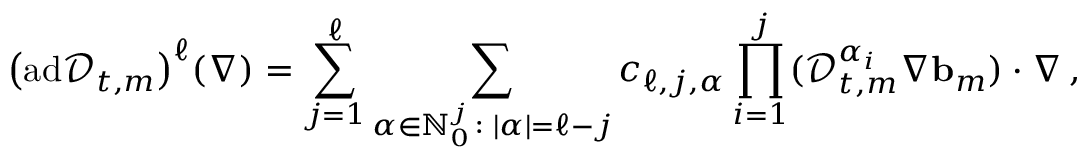<formula> <loc_0><loc_0><loc_500><loc_500>\left ( a d \ m a t h s c r { D } _ { t , m } \right ) ^ { \ell } ( \nabla ) = \sum _ { j = 1 } ^ { \ell } \sum _ { { \alpha } \in { \mathbb { N } } _ { 0 } ^ { j } \colon | { \alpha } | = \ell - j } c _ { \ell , j , { \alpha } } \prod _ { i = 1 } ^ { j } ( \ m a t h s c r { D } _ { t , m } ^ { { \alpha } _ { i } } \nabla { b } _ { m } ) \cdot \nabla \, ,</formula> 